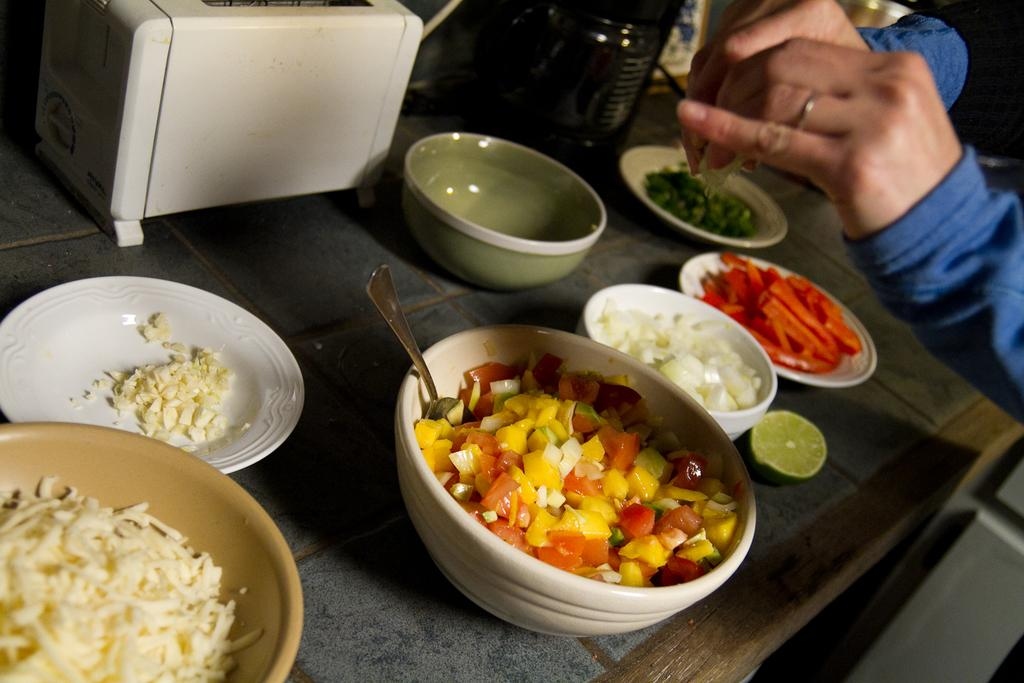What is the main piece of furniture in the image? There is a table in the image. What is placed on the table? There are bowls and a white-colored saucer on the table. Can you describe the white-colored object in the image? There is a white-colored object in the image, but its specific nature is not clear from the provided facts. Who or what is located at the right side of the image? There is a person standing at the right side of the image. What type of art is displayed on the table in the image? There is no art displayed on the table in the image; it contains bowls and a white-colored saucer. What type of soap is used to clean the white-colored object in the image? There is no soap or cleaning activity mentioned in the image, and the nature of the white-colored object is not clear. 